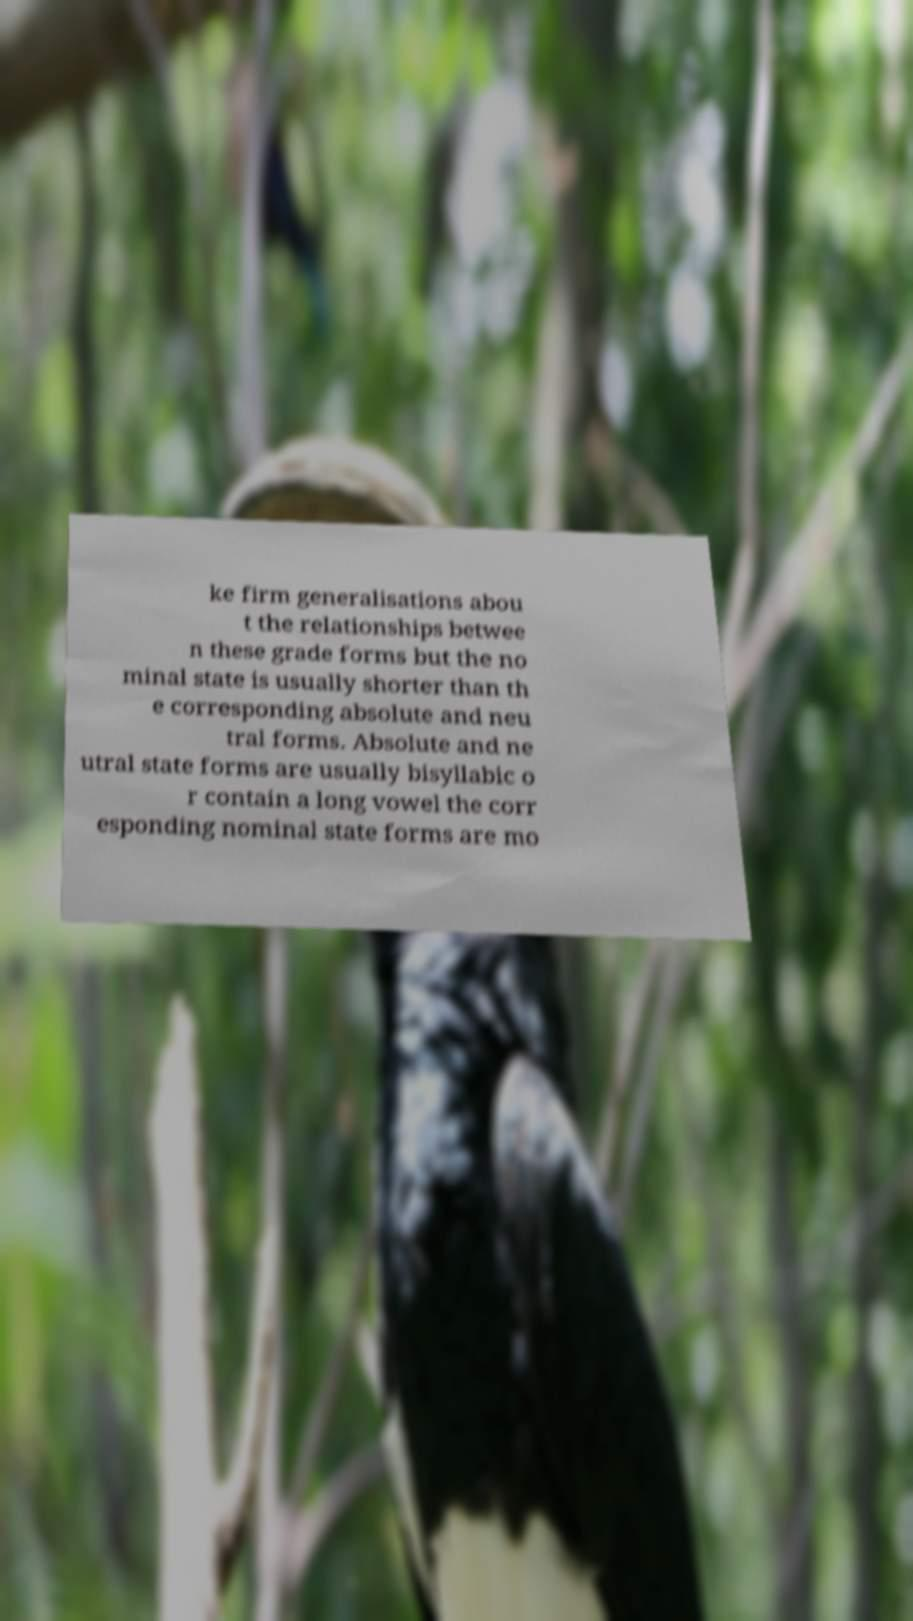Can you read and provide the text displayed in the image?This photo seems to have some interesting text. Can you extract and type it out for me? ke firm generalisations abou t the relationships betwee n these grade forms but the no minal state is usually shorter than th e corresponding absolute and neu tral forms. Absolute and ne utral state forms are usually bisyllabic o r contain a long vowel the corr esponding nominal state forms are mo 